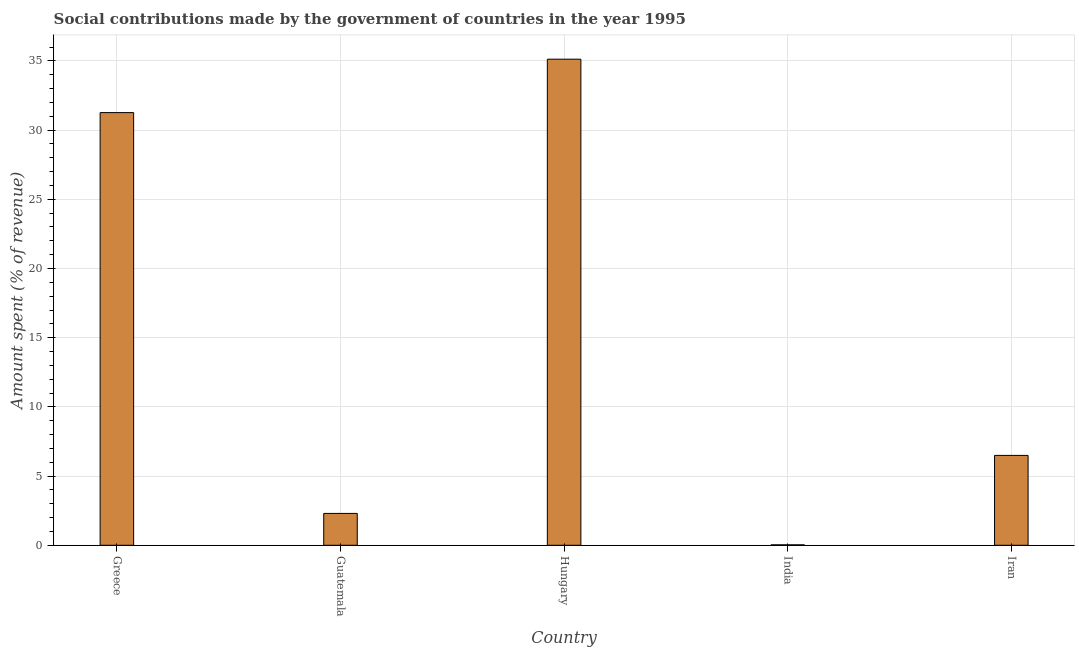What is the title of the graph?
Your answer should be very brief. Social contributions made by the government of countries in the year 1995. What is the label or title of the X-axis?
Provide a succinct answer. Country. What is the label or title of the Y-axis?
Your response must be concise. Amount spent (% of revenue). What is the amount spent in making social contributions in Hungary?
Offer a very short reply. 35.13. Across all countries, what is the maximum amount spent in making social contributions?
Keep it short and to the point. 35.13. Across all countries, what is the minimum amount spent in making social contributions?
Your response must be concise. 0.03. In which country was the amount spent in making social contributions maximum?
Provide a short and direct response. Hungary. What is the sum of the amount spent in making social contributions?
Provide a short and direct response. 75.22. What is the difference between the amount spent in making social contributions in Greece and India?
Your response must be concise. 31.23. What is the average amount spent in making social contributions per country?
Offer a very short reply. 15.04. What is the median amount spent in making social contributions?
Your response must be concise. 6.49. What is the ratio of the amount spent in making social contributions in India to that in Iran?
Offer a very short reply. 0.01. What is the difference between the highest and the second highest amount spent in making social contributions?
Give a very brief answer. 3.86. Is the sum of the amount spent in making social contributions in Hungary and India greater than the maximum amount spent in making social contributions across all countries?
Your answer should be very brief. Yes. What is the difference between the highest and the lowest amount spent in making social contributions?
Your answer should be very brief. 35.09. In how many countries, is the amount spent in making social contributions greater than the average amount spent in making social contributions taken over all countries?
Your answer should be very brief. 2. How many countries are there in the graph?
Your answer should be compact. 5. What is the difference between two consecutive major ticks on the Y-axis?
Your answer should be compact. 5. What is the Amount spent (% of revenue) in Greece?
Provide a short and direct response. 31.27. What is the Amount spent (% of revenue) of Guatemala?
Make the answer very short. 2.3. What is the Amount spent (% of revenue) in Hungary?
Make the answer very short. 35.13. What is the Amount spent (% of revenue) of India?
Provide a succinct answer. 0.03. What is the Amount spent (% of revenue) of Iran?
Your answer should be very brief. 6.49. What is the difference between the Amount spent (% of revenue) in Greece and Guatemala?
Offer a very short reply. 28.96. What is the difference between the Amount spent (% of revenue) in Greece and Hungary?
Ensure brevity in your answer.  -3.86. What is the difference between the Amount spent (% of revenue) in Greece and India?
Your response must be concise. 31.23. What is the difference between the Amount spent (% of revenue) in Greece and Iran?
Offer a terse response. 24.77. What is the difference between the Amount spent (% of revenue) in Guatemala and Hungary?
Offer a terse response. -32.82. What is the difference between the Amount spent (% of revenue) in Guatemala and India?
Your response must be concise. 2.27. What is the difference between the Amount spent (% of revenue) in Guatemala and Iran?
Keep it short and to the point. -4.19. What is the difference between the Amount spent (% of revenue) in Hungary and India?
Offer a very short reply. 35.09. What is the difference between the Amount spent (% of revenue) in Hungary and Iran?
Make the answer very short. 28.63. What is the difference between the Amount spent (% of revenue) in India and Iran?
Your response must be concise. -6.46. What is the ratio of the Amount spent (% of revenue) in Greece to that in Guatemala?
Provide a succinct answer. 13.58. What is the ratio of the Amount spent (% of revenue) in Greece to that in Hungary?
Ensure brevity in your answer.  0.89. What is the ratio of the Amount spent (% of revenue) in Greece to that in India?
Make the answer very short. 983.1. What is the ratio of the Amount spent (% of revenue) in Greece to that in Iran?
Offer a very short reply. 4.81. What is the ratio of the Amount spent (% of revenue) in Guatemala to that in Hungary?
Offer a terse response. 0.07. What is the ratio of the Amount spent (% of revenue) in Guatemala to that in India?
Give a very brief answer. 72.39. What is the ratio of the Amount spent (% of revenue) in Guatemala to that in Iran?
Give a very brief answer. 0.35. What is the ratio of the Amount spent (% of revenue) in Hungary to that in India?
Offer a very short reply. 1104.48. What is the ratio of the Amount spent (% of revenue) in Hungary to that in Iran?
Provide a succinct answer. 5.41. What is the ratio of the Amount spent (% of revenue) in India to that in Iran?
Ensure brevity in your answer.  0.01. 